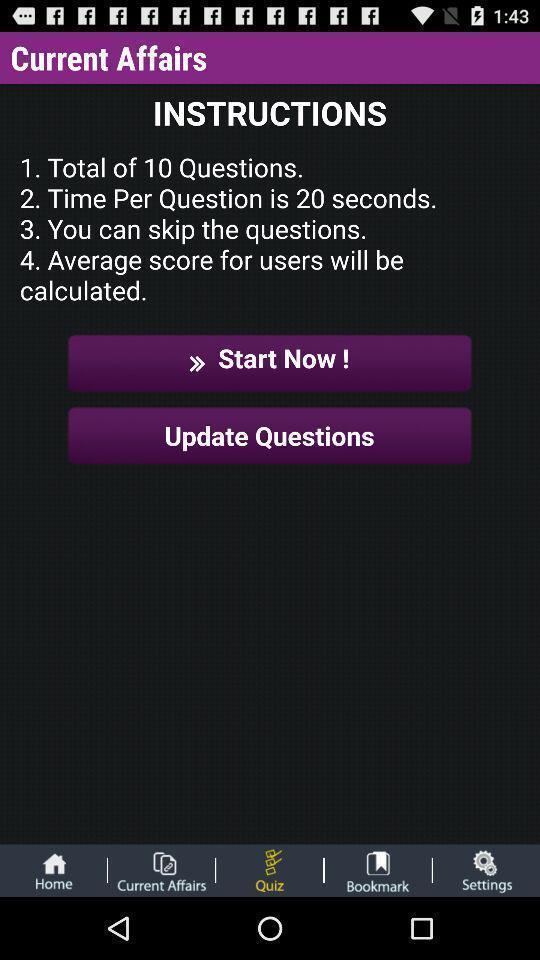Give me a narrative description of this picture. Screen displaying information and other options. 